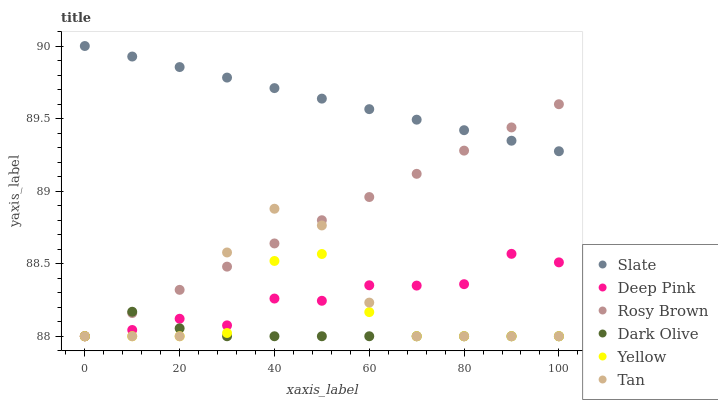Does Dark Olive have the minimum area under the curve?
Answer yes or no. Yes. Does Slate have the maximum area under the curve?
Answer yes or no. Yes. Does Slate have the minimum area under the curve?
Answer yes or no. No. Does Dark Olive have the maximum area under the curve?
Answer yes or no. No. Is Rosy Brown the smoothest?
Answer yes or no. Yes. Is Tan the roughest?
Answer yes or no. Yes. Is Slate the smoothest?
Answer yes or no. No. Is Slate the roughest?
Answer yes or no. No. Does Deep Pink have the lowest value?
Answer yes or no. Yes. Does Slate have the lowest value?
Answer yes or no. No. Does Slate have the highest value?
Answer yes or no. Yes. Does Dark Olive have the highest value?
Answer yes or no. No. Is Yellow less than Slate?
Answer yes or no. Yes. Is Slate greater than Deep Pink?
Answer yes or no. Yes. Does Tan intersect Dark Olive?
Answer yes or no. Yes. Is Tan less than Dark Olive?
Answer yes or no. No. Is Tan greater than Dark Olive?
Answer yes or no. No. Does Yellow intersect Slate?
Answer yes or no. No. 